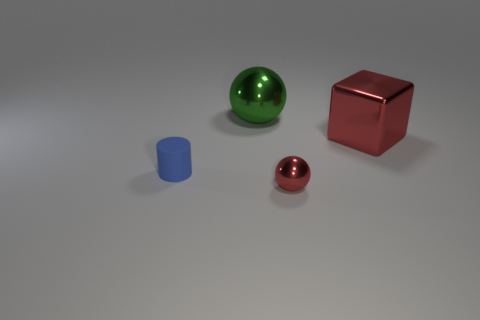Can you infer the lighting direction in this scene? Certainly. The shadows of the objects are projecting toward the bottom right of the image, which indicates that the primary light source is located to the top left of the scene. There's also a soft shadowing effect under the objects that suggests diffused lighting, contributing to the gentle contrast on the surfaces. 